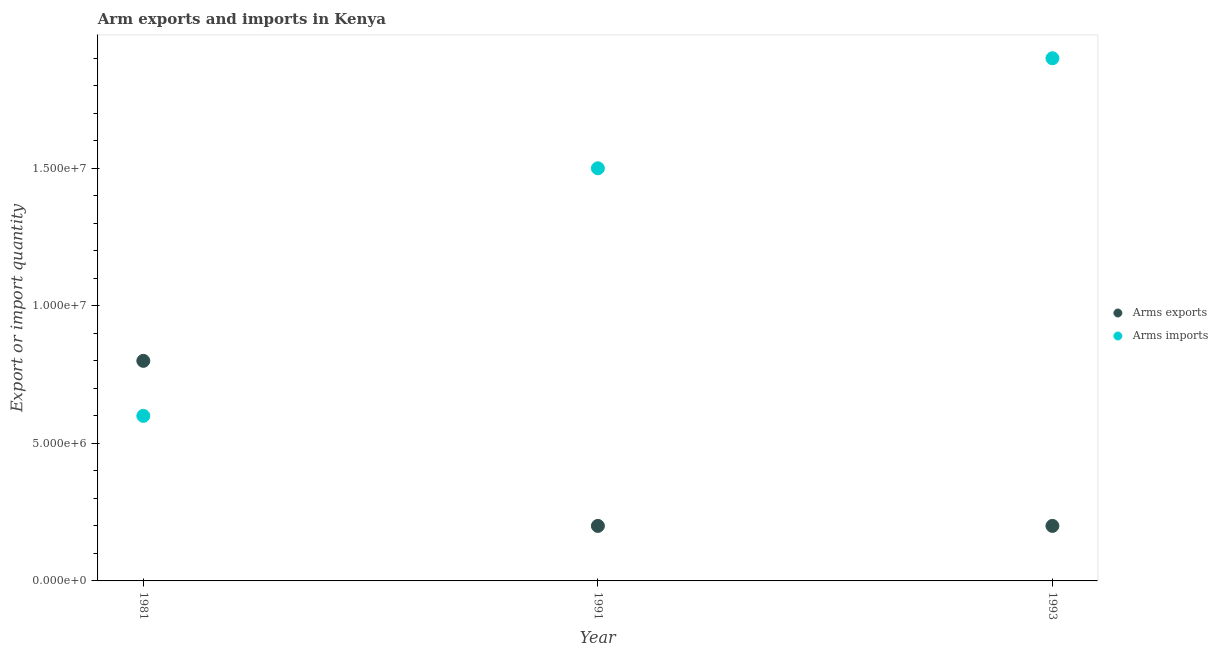What is the arms exports in 1981?
Provide a succinct answer. 8.00e+06. Across all years, what is the maximum arms imports?
Give a very brief answer. 1.90e+07. Across all years, what is the minimum arms imports?
Your response must be concise. 6.00e+06. In which year was the arms imports maximum?
Provide a short and direct response. 1993. What is the total arms imports in the graph?
Your answer should be very brief. 4.00e+07. What is the difference between the arms imports in 1991 and that in 1993?
Your answer should be very brief. -4.00e+06. What is the difference between the arms exports in 1981 and the arms imports in 1993?
Keep it short and to the point. -1.10e+07. What is the average arms imports per year?
Provide a succinct answer. 1.33e+07. In the year 1993, what is the difference between the arms imports and arms exports?
Your response must be concise. 1.70e+07. In how many years, is the arms imports greater than 17000000?
Give a very brief answer. 1. What is the ratio of the arms exports in 1991 to that in 1993?
Keep it short and to the point. 1. Is the arms exports in 1981 less than that in 1993?
Make the answer very short. No. Is the difference between the arms exports in 1981 and 1993 greater than the difference between the arms imports in 1981 and 1993?
Provide a succinct answer. Yes. What is the difference between the highest and the lowest arms imports?
Offer a very short reply. 1.30e+07. In how many years, is the arms imports greater than the average arms imports taken over all years?
Give a very brief answer. 2. Does the arms imports monotonically increase over the years?
Offer a very short reply. Yes. Is the arms imports strictly greater than the arms exports over the years?
Provide a short and direct response. No. How many dotlines are there?
Offer a very short reply. 2. How many years are there in the graph?
Provide a short and direct response. 3. What is the difference between two consecutive major ticks on the Y-axis?
Your answer should be compact. 5.00e+06. Does the graph contain any zero values?
Your answer should be very brief. No. Does the graph contain grids?
Your answer should be very brief. No. Where does the legend appear in the graph?
Provide a short and direct response. Center right. How many legend labels are there?
Your answer should be very brief. 2. What is the title of the graph?
Provide a short and direct response. Arm exports and imports in Kenya. What is the label or title of the Y-axis?
Provide a short and direct response. Export or import quantity. What is the Export or import quantity in Arms exports in 1981?
Provide a short and direct response. 8.00e+06. What is the Export or import quantity in Arms imports in 1991?
Keep it short and to the point. 1.50e+07. What is the Export or import quantity of Arms imports in 1993?
Keep it short and to the point. 1.90e+07. Across all years, what is the maximum Export or import quantity of Arms exports?
Ensure brevity in your answer.  8.00e+06. Across all years, what is the maximum Export or import quantity of Arms imports?
Give a very brief answer. 1.90e+07. Across all years, what is the minimum Export or import quantity of Arms imports?
Make the answer very short. 6.00e+06. What is the total Export or import quantity in Arms exports in the graph?
Give a very brief answer. 1.20e+07. What is the total Export or import quantity in Arms imports in the graph?
Your answer should be very brief. 4.00e+07. What is the difference between the Export or import quantity of Arms imports in 1981 and that in 1991?
Your answer should be very brief. -9.00e+06. What is the difference between the Export or import quantity of Arms exports in 1981 and that in 1993?
Provide a short and direct response. 6.00e+06. What is the difference between the Export or import quantity of Arms imports in 1981 and that in 1993?
Give a very brief answer. -1.30e+07. What is the difference between the Export or import quantity of Arms exports in 1991 and that in 1993?
Your answer should be compact. 0. What is the difference between the Export or import quantity in Arms imports in 1991 and that in 1993?
Give a very brief answer. -4.00e+06. What is the difference between the Export or import quantity in Arms exports in 1981 and the Export or import quantity in Arms imports in 1991?
Ensure brevity in your answer.  -7.00e+06. What is the difference between the Export or import quantity of Arms exports in 1981 and the Export or import quantity of Arms imports in 1993?
Your answer should be compact. -1.10e+07. What is the difference between the Export or import quantity in Arms exports in 1991 and the Export or import quantity in Arms imports in 1993?
Offer a very short reply. -1.70e+07. What is the average Export or import quantity of Arms exports per year?
Your answer should be compact. 4.00e+06. What is the average Export or import quantity of Arms imports per year?
Ensure brevity in your answer.  1.33e+07. In the year 1991, what is the difference between the Export or import quantity of Arms exports and Export or import quantity of Arms imports?
Offer a terse response. -1.30e+07. In the year 1993, what is the difference between the Export or import quantity in Arms exports and Export or import quantity in Arms imports?
Offer a terse response. -1.70e+07. What is the ratio of the Export or import quantity in Arms exports in 1981 to that in 1993?
Your response must be concise. 4. What is the ratio of the Export or import quantity in Arms imports in 1981 to that in 1993?
Your response must be concise. 0.32. What is the ratio of the Export or import quantity of Arms imports in 1991 to that in 1993?
Ensure brevity in your answer.  0.79. What is the difference between the highest and the second highest Export or import quantity of Arms imports?
Provide a succinct answer. 4.00e+06. What is the difference between the highest and the lowest Export or import quantity in Arms exports?
Your response must be concise. 6.00e+06. What is the difference between the highest and the lowest Export or import quantity of Arms imports?
Your response must be concise. 1.30e+07. 